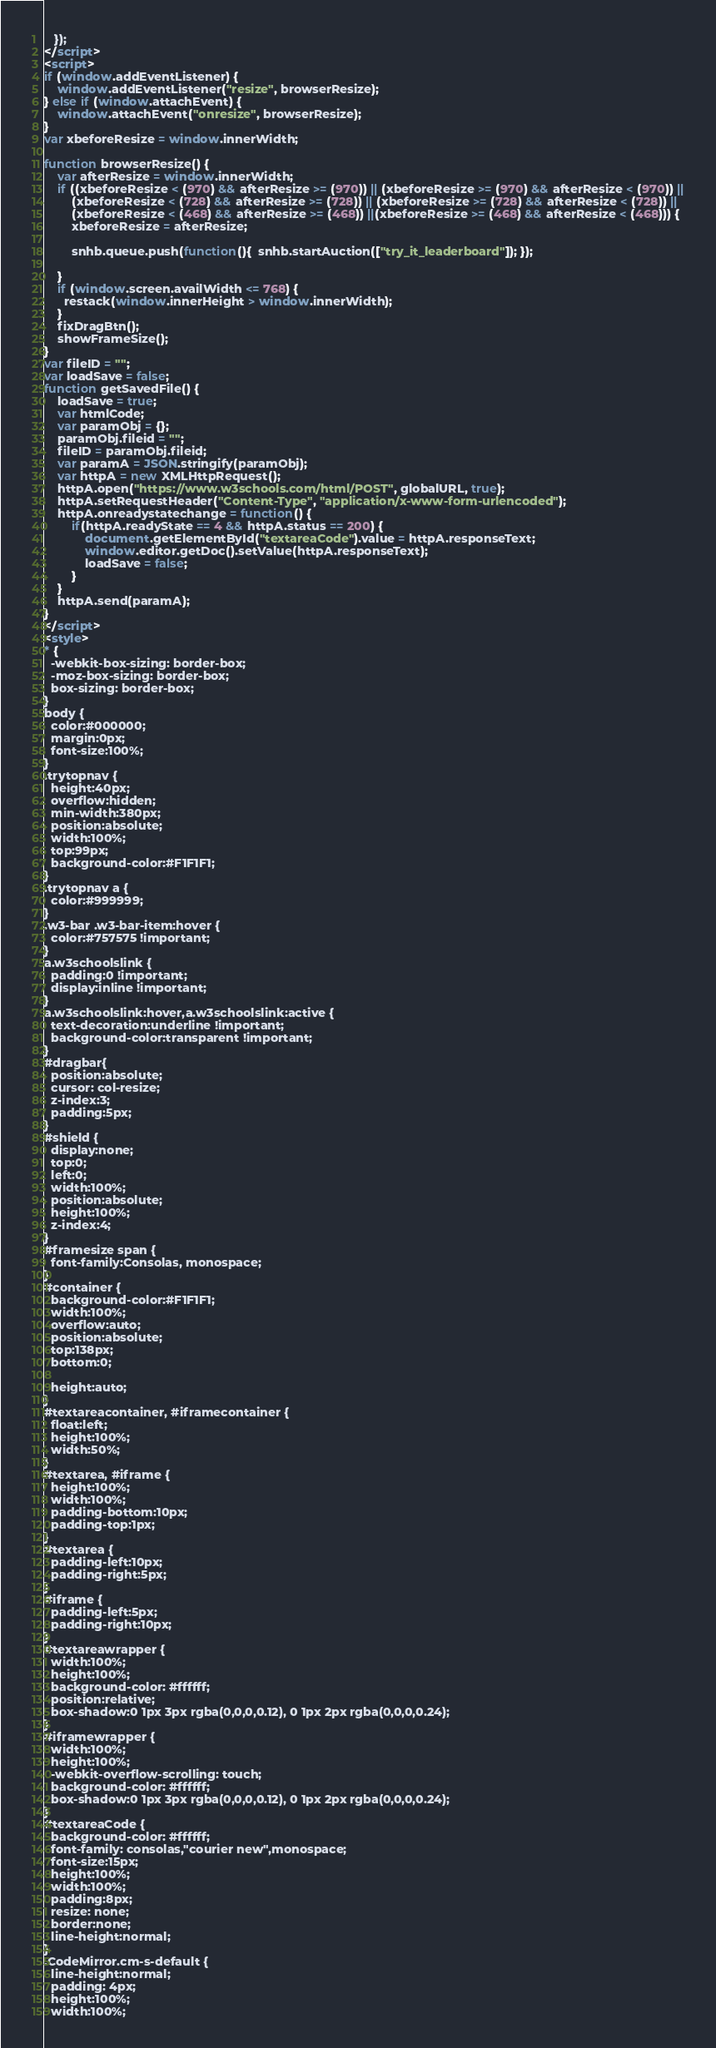<code> <loc_0><loc_0><loc_500><loc_500><_HTML_>
   });
</script>
<script>
if (window.addEventListener) {              
    window.addEventListener("resize", browserResize);
} else if (window.attachEvent) {                 
    window.attachEvent("onresize", browserResize);
}
var xbeforeResize = window.innerWidth;

function browserResize() {
    var afterResize = window.innerWidth;
    if ((xbeforeResize < (970) && afterResize >= (970)) || (xbeforeResize >= (970) && afterResize < (970)) ||
        (xbeforeResize < (728) && afterResize >= (728)) || (xbeforeResize >= (728) && afterResize < (728)) ||
        (xbeforeResize < (468) && afterResize >= (468)) ||(xbeforeResize >= (468) && afterResize < (468))) {
        xbeforeResize = afterResize;
        
        snhb.queue.push(function(){  snhb.startAuction(["try_it_leaderboard"]); });
         
    }
    if (window.screen.availWidth <= 768) {
      restack(window.innerHeight > window.innerWidth);
    }
    fixDragBtn();
    showFrameSize();    
}
var fileID = "";
var loadSave = false;
function getSavedFile() {
    loadSave = true;
    var htmlCode;
    var paramObj = {};
    paramObj.fileid = "";
    fileID = paramObj.fileid;
    var paramA = JSON.stringify(paramObj);
    var httpA = new XMLHttpRequest();
    httpA.open("https://www.w3schools.com/html/POST", globalURL, true);
    httpA.setRequestHeader("Content-Type", "application/x-www-form-urlencoded");
    httpA.onreadystatechange = function() {
        if(httpA.readyState == 4 && httpA.status == 200) {
            document.getElementById("textareaCode").value = httpA.responseText;
            window.editor.getDoc().setValue(httpA.responseText);
            loadSave = false;
        }
    }
    httpA.send(paramA);   
}
</script>
<style>
* {
  -webkit-box-sizing: border-box;
  -moz-box-sizing: border-box;
  box-sizing: border-box;
}
body {
  color:#000000;
  margin:0px;
  font-size:100%;
}
.trytopnav {
  height:40px;
  overflow:hidden;
  min-width:380px;
  position:absolute;
  width:100%;
  top:99px;
  background-color:#F1F1F1;
}
.trytopnav a {
  color:#999999;
}
.w3-bar .w3-bar-item:hover {
  color:#757575 !important;
}
a.w3schoolslink {
  padding:0 !important;
  display:inline !important;
}
a.w3schoolslink:hover,a.w3schoolslink:active {
  text-decoration:underline !important;
  background-color:transparent !important;
}
#dragbar{
  position:absolute;
  cursor: col-resize;
  z-index:3;
  padding:5px;
}
#shield {
  display:none;
  top:0;
  left:0;
  width:100%;
  position:absolute;
  height:100%;
  z-index:4;
}
#framesize span {
  font-family:Consolas, monospace;
}
#container {
  background-color:#F1F1F1;
  width:100%;
  overflow:auto;
  position:absolute;
  top:138px;
  bottom:0;

  height:auto;
}
#textareacontainer, #iframecontainer {
  float:left;
  height:100%;
  width:50%;
}
#textarea, #iframe {
  height:100%;
  width:100%;
  padding-bottom:10px;
  padding-top:1px;
}
#textarea {
  padding-left:10px;
  padding-right:5px;  
}
#iframe {
  padding-left:5px;
  padding-right:10px;  
}
#textareawrapper {
  width:100%;
  height:100%;
  background-color: #ffffff;
  position:relative;
  box-shadow:0 1px 3px rgba(0,0,0,0.12), 0 1px 2px rgba(0,0,0,0.24);
}
#iframewrapper {
  width:100%;
  height:100%;
  -webkit-overflow-scrolling: touch;
  background-color: #ffffff;
  box-shadow:0 1px 3px rgba(0,0,0,0.12), 0 1px 2px rgba(0,0,0,0.24);
}
#textareaCode {
  background-color: #ffffff;
  font-family: consolas,"courier new",monospace;
  font-size:15px;
  height:100%;
  width:100%;
  padding:8px;
  resize: none;
  border:none;
  line-height:normal;    
}
.CodeMirror.cm-s-default {
  line-height:normal;
  padding: 4px;
  height:100%;
  width:100%;</code> 